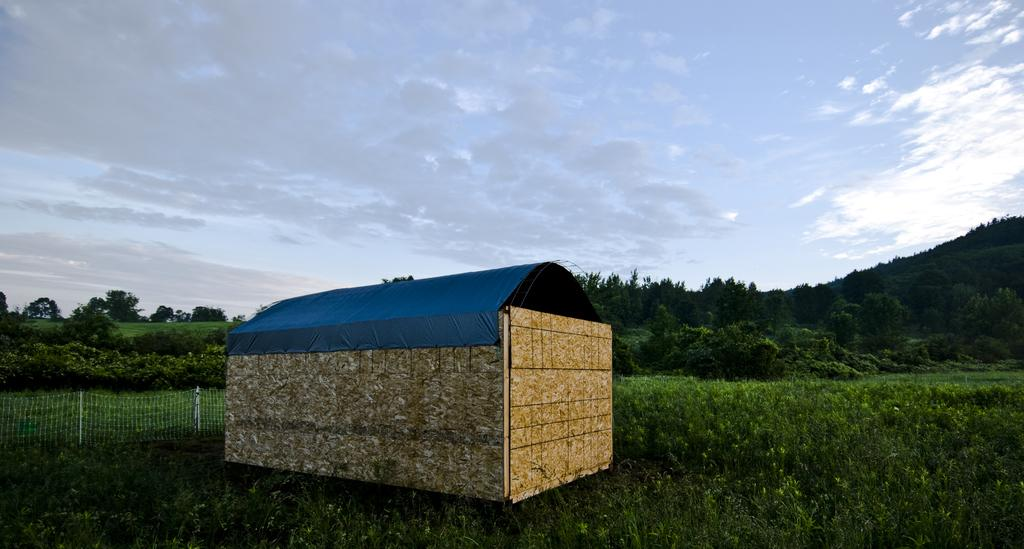What is located in the foreground of the image? There is a shelter in the foreground of the image. What is surrounding the shelter? There are plants around the shelter. What can be seen behind the shelter? There is fencing behind the shelter. What is visible in the background of the image? There are trees and the sky in the background of the image. Can you describe the sky in the image? The sky is visible in the background of the image, and there is a cloud present. What type of cord is hanging from the tree in the image? There is no cord hanging from the tree in the image; only plants, shelter, fencing, trees, and sky are present. What is the weight of the stew being cooked in the image? There is no stew being cooked in the image; it features a shelter, plants, fencing, trees, and sky. 